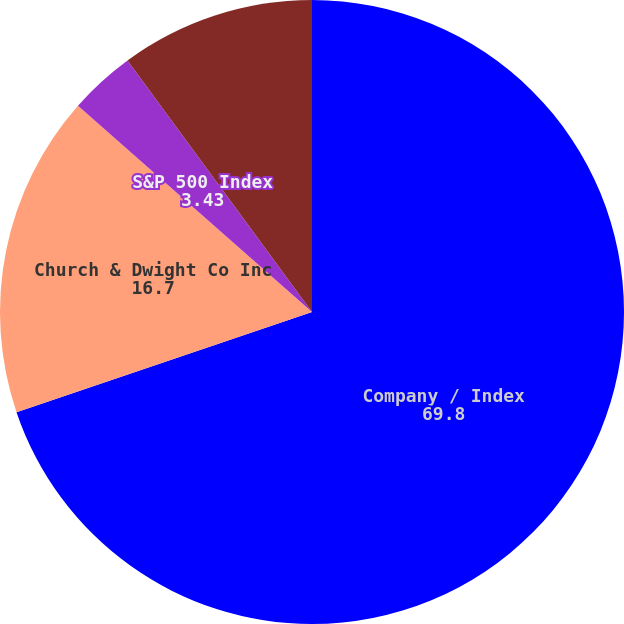Convert chart to OTSL. <chart><loc_0><loc_0><loc_500><loc_500><pie_chart><fcel>Company / Index<fcel>Church & Dwight Co Inc<fcel>S&P 500 Index<fcel>S&P 500 Household Products<nl><fcel>69.8%<fcel>16.7%<fcel>3.43%<fcel>10.07%<nl></chart> 